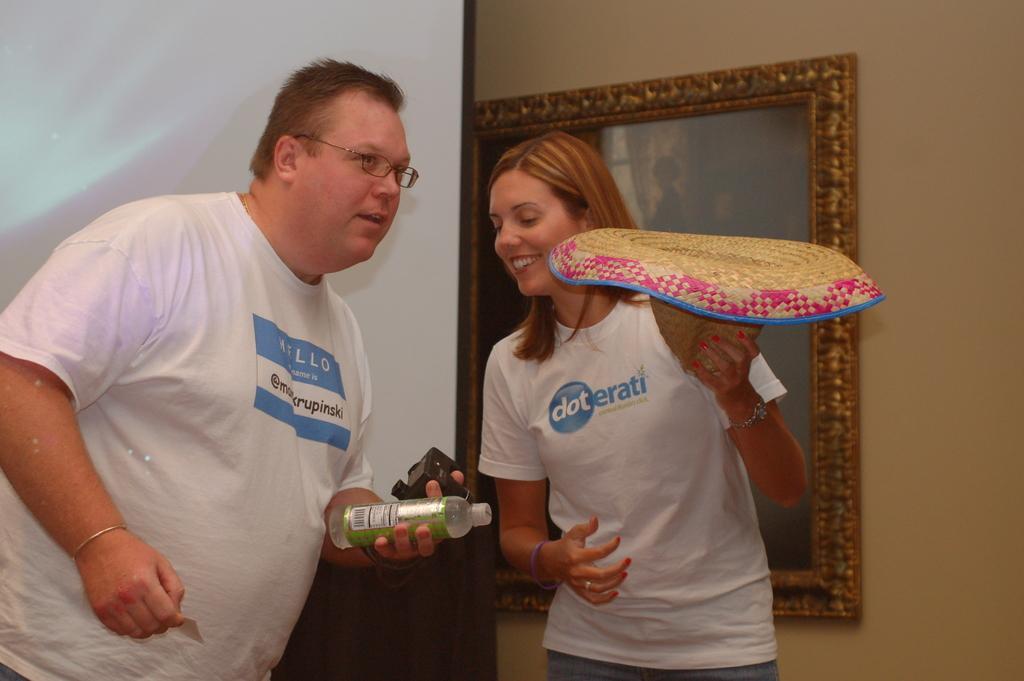In one or two sentences, can you explain what this image depicts? In this picture there is a man and woman smiling and the man has water bottle in his left hand 